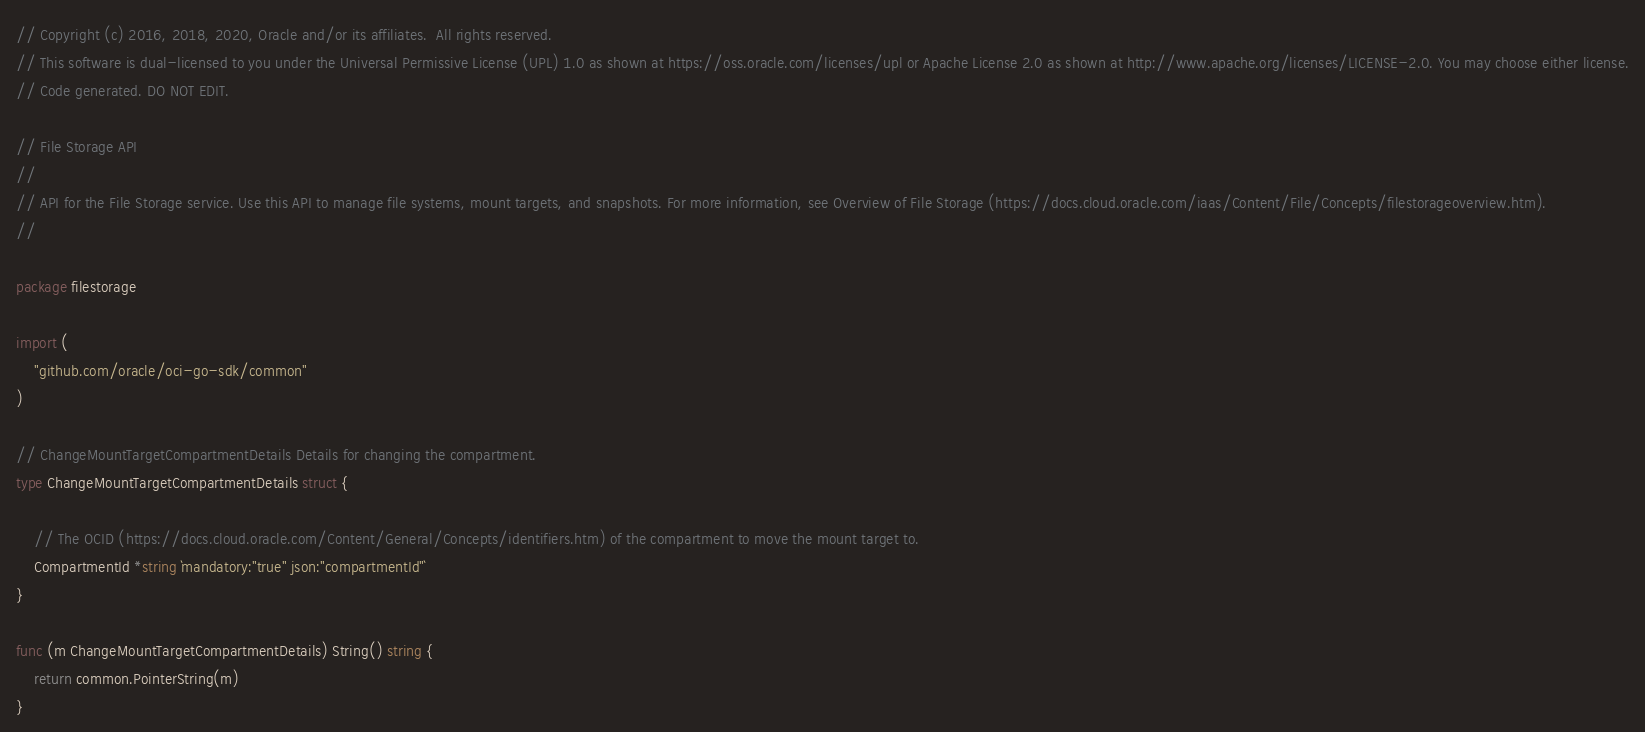Convert code to text. <code><loc_0><loc_0><loc_500><loc_500><_Go_>// Copyright (c) 2016, 2018, 2020, Oracle and/or its affiliates.  All rights reserved.
// This software is dual-licensed to you under the Universal Permissive License (UPL) 1.0 as shown at https://oss.oracle.com/licenses/upl or Apache License 2.0 as shown at http://www.apache.org/licenses/LICENSE-2.0. You may choose either license.
// Code generated. DO NOT EDIT.

// File Storage API
//
// API for the File Storage service. Use this API to manage file systems, mount targets, and snapshots. For more information, see Overview of File Storage (https://docs.cloud.oracle.com/iaas/Content/File/Concepts/filestorageoverview.htm).
//

package filestorage

import (
	"github.com/oracle/oci-go-sdk/common"
)

// ChangeMountTargetCompartmentDetails Details for changing the compartment.
type ChangeMountTargetCompartmentDetails struct {

	// The OCID (https://docs.cloud.oracle.com/Content/General/Concepts/identifiers.htm) of the compartment to move the mount target to.
	CompartmentId *string `mandatory:"true" json:"compartmentId"`
}

func (m ChangeMountTargetCompartmentDetails) String() string {
	return common.PointerString(m)
}
</code> 